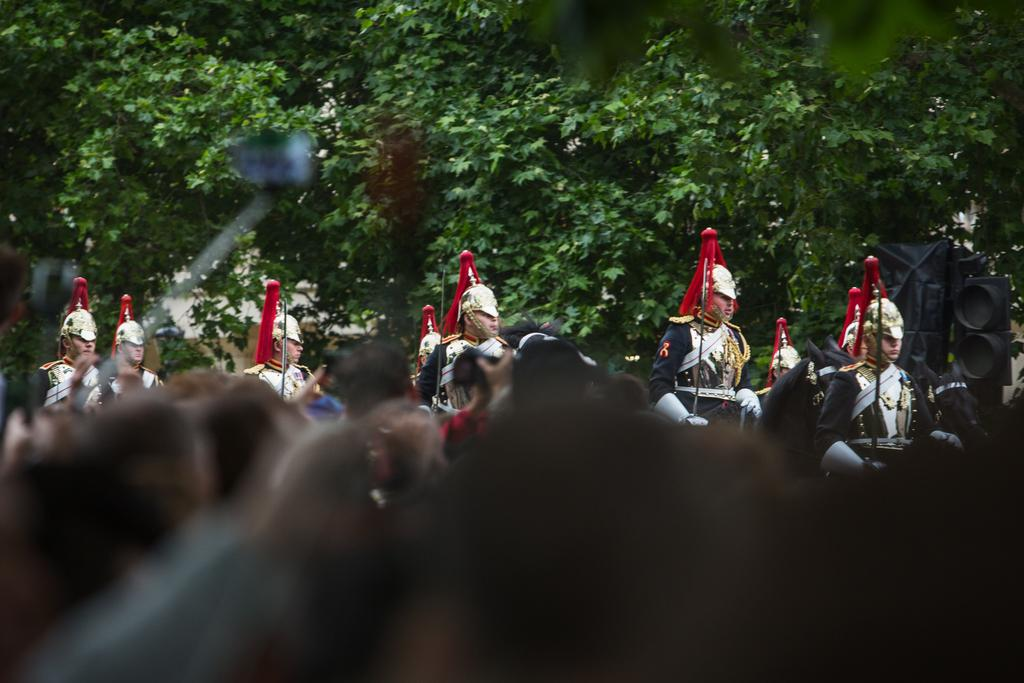What is the main subject of the image? The main subject of the image is a crowd. Can you describe anything happening in the background? Yes, there is a horse marching in the background. What type of natural scenery can be seen in the image? Trees are visible in the background. What type of wire is being used to make a statement in the image? There is no wire or statement being made in the image; it features a crowd and a horse marching in the background. 